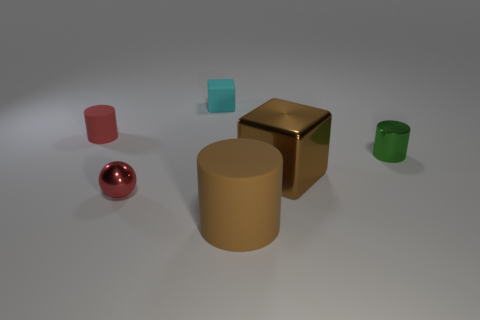Add 1 small cyan rubber things. How many objects exist? 7 Subtract all balls. How many objects are left? 5 Add 5 metallic balls. How many metallic balls exist? 6 Subtract 1 brown cylinders. How many objects are left? 5 Subtract all big yellow balls. Subtract all small cylinders. How many objects are left? 4 Add 3 big matte cylinders. How many big matte cylinders are left? 4 